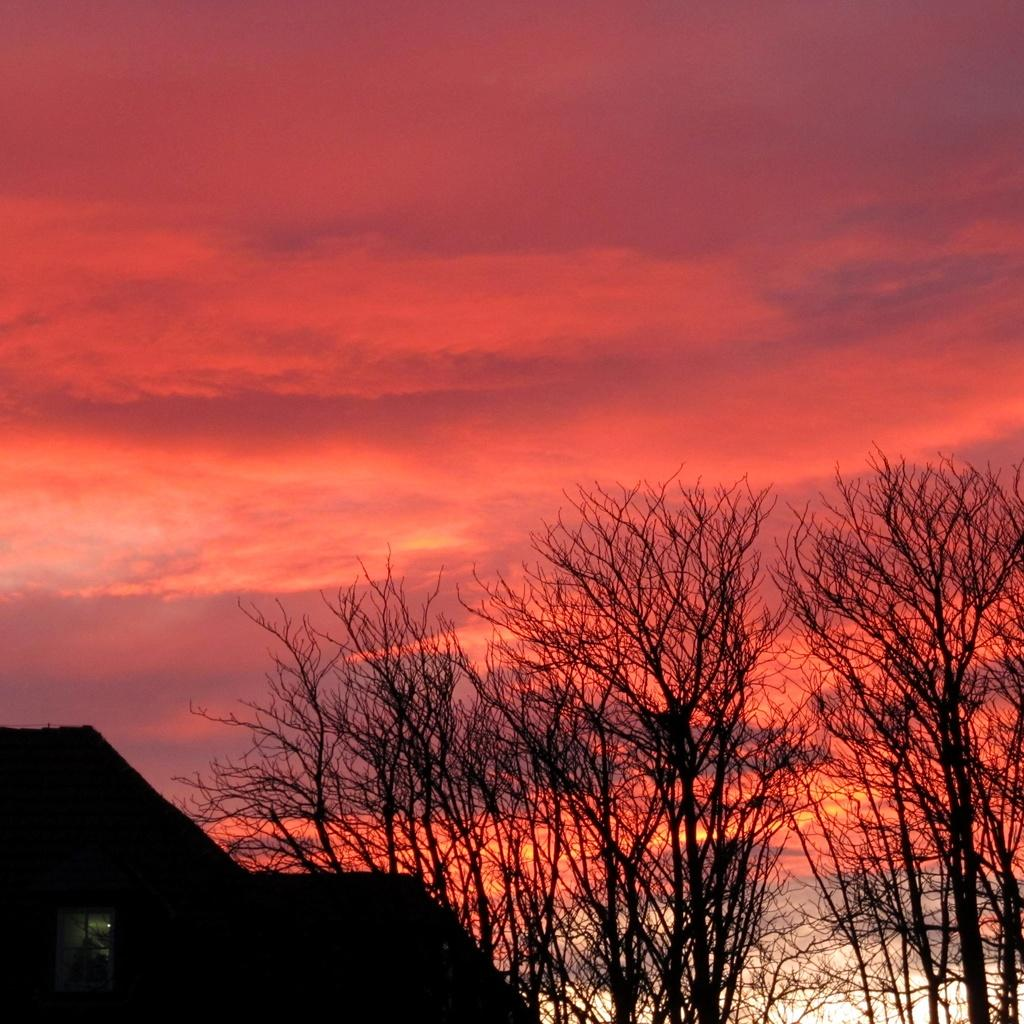What type of structure is visible in the image? There is a house in the image. What other natural elements can be seen in the image? There is a group of trees in the image. What is visible in the background of the image? The sky is visible in the image. How would you describe the weather based on the appearance of the sky? The sky appears to be cloudy in the image. How many minutes does it take for the chickens to cross the road in the image? There are no chickens present in the image, so it is not possible to determine how long it would take for them to cross a road. 